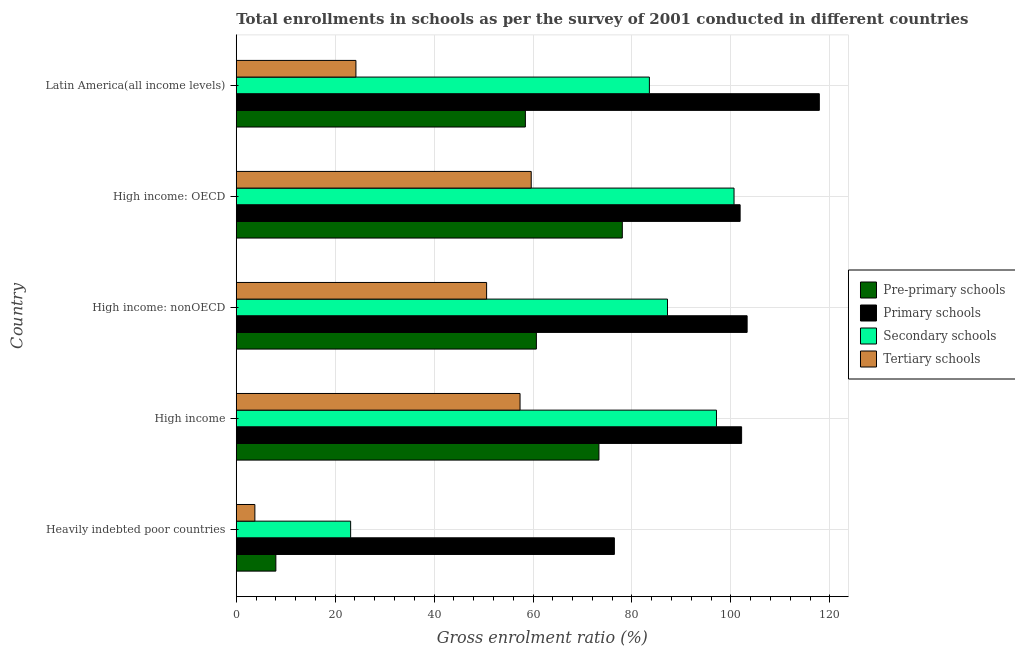Are the number of bars per tick equal to the number of legend labels?
Your answer should be compact. Yes. How many bars are there on the 1st tick from the top?
Offer a terse response. 4. How many bars are there on the 5th tick from the bottom?
Your answer should be very brief. 4. What is the label of the 2nd group of bars from the top?
Your response must be concise. High income: OECD. In how many cases, is the number of bars for a given country not equal to the number of legend labels?
Give a very brief answer. 0. What is the gross enrolment ratio in primary schools in High income: OECD?
Provide a short and direct response. 101.87. Across all countries, what is the maximum gross enrolment ratio in tertiary schools?
Keep it short and to the point. 59.63. Across all countries, what is the minimum gross enrolment ratio in tertiary schools?
Your response must be concise. 3.76. In which country was the gross enrolment ratio in primary schools maximum?
Make the answer very short. Latin America(all income levels). In which country was the gross enrolment ratio in secondary schools minimum?
Your response must be concise. Heavily indebted poor countries. What is the total gross enrolment ratio in pre-primary schools in the graph?
Your answer should be compact. 278.52. What is the difference between the gross enrolment ratio in primary schools in Heavily indebted poor countries and that in High income: OECD?
Make the answer very short. -25.42. What is the difference between the gross enrolment ratio in secondary schools in High income and the gross enrolment ratio in primary schools in High income: OECD?
Your answer should be compact. -4.78. What is the average gross enrolment ratio in pre-primary schools per country?
Your response must be concise. 55.7. What is the difference between the gross enrolment ratio in secondary schools and gross enrolment ratio in pre-primary schools in High income: nonOECD?
Make the answer very short. 26.51. What is the ratio of the gross enrolment ratio in pre-primary schools in High income to that in High income: OECD?
Offer a terse response. 0.94. What is the difference between the highest and the second highest gross enrolment ratio in pre-primary schools?
Ensure brevity in your answer.  4.73. What is the difference between the highest and the lowest gross enrolment ratio in secondary schools?
Provide a succinct answer. 77.51. Is the sum of the gross enrolment ratio in pre-primary schools in High income: OECD and High income: nonOECD greater than the maximum gross enrolment ratio in secondary schools across all countries?
Give a very brief answer. Yes. Is it the case that in every country, the sum of the gross enrolment ratio in tertiary schools and gross enrolment ratio in pre-primary schools is greater than the sum of gross enrolment ratio in primary schools and gross enrolment ratio in secondary schools?
Give a very brief answer. No. What does the 4th bar from the top in High income: OECD represents?
Give a very brief answer. Pre-primary schools. What does the 2nd bar from the bottom in High income represents?
Keep it short and to the point. Primary schools. Is it the case that in every country, the sum of the gross enrolment ratio in pre-primary schools and gross enrolment ratio in primary schools is greater than the gross enrolment ratio in secondary schools?
Your answer should be very brief. Yes. How many bars are there?
Offer a terse response. 20. Are all the bars in the graph horizontal?
Provide a succinct answer. Yes. What is the difference between two consecutive major ticks on the X-axis?
Give a very brief answer. 20. Where does the legend appear in the graph?
Ensure brevity in your answer.  Center right. How many legend labels are there?
Your answer should be very brief. 4. How are the legend labels stacked?
Keep it short and to the point. Vertical. What is the title of the graph?
Make the answer very short. Total enrollments in schools as per the survey of 2001 conducted in different countries. Does "Finland" appear as one of the legend labels in the graph?
Provide a short and direct response. No. What is the label or title of the X-axis?
Make the answer very short. Gross enrolment ratio (%). What is the Gross enrolment ratio (%) in Pre-primary schools in Heavily indebted poor countries?
Your answer should be very brief. 8.01. What is the Gross enrolment ratio (%) in Primary schools in Heavily indebted poor countries?
Your answer should be very brief. 76.45. What is the Gross enrolment ratio (%) in Secondary schools in Heavily indebted poor countries?
Provide a succinct answer. 23.13. What is the Gross enrolment ratio (%) of Tertiary schools in Heavily indebted poor countries?
Ensure brevity in your answer.  3.76. What is the Gross enrolment ratio (%) of Pre-primary schools in High income?
Provide a succinct answer. 73.33. What is the Gross enrolment ratio (%) in Primary schools in High income?
Your answer should be compact. 102.17. What is the Gross enrolment ratio (%) of Secondary schools in High income?
Offer a very short reply. 97.09. What is the Gross enrolment ratio (%) of Tertiary schools in High income?
Offer a terse response. 57.38. What is the Gross enrolment ratio (%) in Pre-primary schools in High income: nonOECD?
Provide a succinct answer. 60.68. What is the Gross enrolment ratio (%) of Primary schools in High income: nonOECD?
Your response must be concise. 103.29. What is the Gross enrolment ratio (%) in Secondary schools in High income: nonOECD?
Make the answer very short. 87.19. What is the Gross enrolment ratio (%) in Tertiary schools in High income: nonOECD?
Keep it short and to the point. 50.62. What is the Gross enrolment ratio (%) of Pre-primary schools in High income: OECD?
Your answer should be compact. 78.05. What is the Gross enrolment ratio (%) of Primary schools in High income: OECD?
Offer a very short reply. 101.87. What is the Gross enrolment ratio (%) in Secondary schools in High income: OECD?
Keep it short and to the point. 100.64. What is the Gross enrolment ratio (%) in Tertiary schools in High income: OECD?
Ensure brevity in your answer.  59.63. What is the Gross enrolment ratio (%) in Pre-primary schools in Latin America(all income levels)?
Your answer should be compact. 58.45. What is the Gross enrolment ratio (%) in Primary schools in Latin America(all income levels)?
Provide a succinct answer. 117.88. What is the Gross enrolment ratio (%) of Secondary schools in Latin America(all income levels)?
Your response must be concise. 83.53. What is the Gross enrolment ratio (%) of Tertiary schools in Latin America(all income levels)?
Offer a very short reply. 24.19. Across all countries, what is the maximum Gross enrolment ratio (%) in Pre-primary schools?
Ensure brevity in your answer.  78.05. Across all countries, what is the maximum Gross enrolment ratio (%) in Primary schools?
Keep it short and to the point. 117.88. Across all countries, what is the maximum Gross enrolment ratio (%) of Secondary schools?
Give a very brief answer. 100.64. Across all countries, what is the maximum Gross enrolment ratio (%) of Tertiary schools?
Your response must be concise. 59.63. Across all countries, what is the minimum Gross enrolment ratio (%) in Pre-primary schools?
Offer a terse response. 8.01. Across all countries, what is the minimum Gross enrolment ratio (%) in Primary schools?
Ensure brevity in your answer.  76.45. Across all countries, what is the minimum Gross enrolment ratio (%) of Secondary schools?
Offer a terse response. 23.13. Across all countries, what is the minimum Gross enrolment ratio (%) of Tertiary schools?
Offer a very short reply. 3.76. What is the total Gross enrolment ratio (%) in Pre-primary schools in the graph?
Make the answer very short. 278.52. What is the total Gross enrolment ratio (%) in Primary schools in the graph?
Offer a very short reply. 501.66. What is the total Gross enrolment ratio (%) of Secondary schools in the graph?
Keep it short and to the point. 391.57. What is the total Gross enrolment ratio (%) in Tertiary schools in the graph?
Keep it short and to the point. 195.58. What is the difference between the Gross enrolment ratio (%) of Pre-primary schools in Heavily indebted poor countries and that in High income?
Give a very brief answer. -65.32. What is the difference between the Gross enrolment ratio (%) in Primary schools in Heavily indebted poor countries and that in High income?
Provide a succinct answer. -25.72. What is the difference between the Gross enrolment ratio (%) of Secondary schools in Heavily indebted poor countries and that in High income?
Provide a short and direct response. -73.96. What is the difference between the Gross enrolment ratio (%) of Tertiary schools in Heavily indebted poor countries and that in High income?
Keep it short and to the point. -53.61. What is the difference between the Gross enrolment ratio (%) in Pre-primary schools in Heavily indebted poor countries and that in High income: nonOECD?
Provide a succinct answer. -52.67. What is the difference between the Gross enrolment ratio (%) of Primary schools in Heavily indebted poor countries and that in High income: nonOECD?
Provide a short and direct response. -26.84. What is the difference between the Gross enrolment ratio (%) in Secondary schools in Heavily indebted poor countries and that in High income: nonOECD?
Offer a terse response. -64.06. What is the difference between the Gross enrolment ratio (%) in Tertiary schools in Heavily indebted poor countries and that in High income: nonOECD?
Offer a very short reply. -46.85. What is the difference between the Gross enrolment ratio (%) of Pre-primary schools in Heavily indebted poor countries and that in High income: OECD?
Offer a terse response. -70.05. What is the difference between the Gross enrolment ratio (%) in Primary schools in Heavily indebted poor countries and that in High income: OECD?
Your answer should be compact. -25.42. What is the difference between the Gross enrolment ratio (%) in Secondary schools in Heavily indebted poor countries and that in High income: OECD?
Your answer should be compact. -77.51. What is the difference between the Gross enrolment ratio (%) of Tertiary schools in Heavily indebted poor countries and that in High income: OECD?
Your answer should be very brief. -55.87. What is the difference between the Gross enrolment ratio (%) in Pre-primary schools in Heavily indebted poor countries and that in Latin America(all income levels)?
Keep it short and to the point. -50.45. What is the difference between the Gross enrolment ratio (%) of Primary schools in Heavily indebted poor countries and that in Latin America(all income levels)?
Give a very brief answer. -41.44. What is the difference between the Gross enrolment ratio (%) in Secondary schools in Heavily indebted poor countries and that in Latin America(all income levels)?
Offer a very short reply. -60.4. What is the difference between the Gross enrolment ratio (%) of Tertiary schools in Heavily indebted poor countries and that in Latin America(all income levels)?
Your answer should be compact. -20.43. What is the difference between the Gross enrolment ratio (%) in Pre-primary schools in High income and that in High income: nonOECD?
Keep it short and to the point. 12.65. What is the difference between the Gross enrolment ratio (%) of Primary schools in High income and that in High income: nonOECD?
Your response must be concise. -1.11. What is the difference between the Gross enrolment ratio (%) of Secondary schools in High income and that in High income: nonOECD?
Your answer should be very brief. 9.9. What is the difference between the Gross enrolment ratio (%) in Tertiary schools in High income and that in High income: nonOECD?
Keep it short and to the point. 6.76. What is the difference between the Gross enrolment ratio (%) in Pre-primary schools in High income and that in High income: OECD?
Your answer should be compact. -4.73. What is the difference between the Gross enrolment ratio (%) in Primary schools in High income and that in High income: OECD?
Keep it short and to the point. 0.3. What is the difference between the Gross enrolment ratio (%) in Secondary schools in High income and that in High income: OECD?
Provide a succinct answer. -3.55. What is the difference between the Gross enrolment ratio (%) in Tertiary schools in High income and that in High income: OECD?
Offer a very short reply. -2.26. What is the difference between the Gross enrolment ratio (%) of Pre-primary schools in High income and that in Latin America(all income levels)?
Ensure brevity in your answer.  14.87. What is the difference between the Gross enrolment ratio (%) of Primary schools in High income and that in Latin America(all income levels)?
Give a very brief answer. -15.71. What is the difference between the Gross enrolment ratio (%) in Secondary schools in High income and that in Latin America(all income levels)?
Make the answer very short. 13.56. What is the difference between the Gross enrolment ratio (%) of Tertiary schools in High income and that in Latin America(all income levels)?
Offer a terse response. 33.18. What is the difference between the Gross enrolment ratio (%) in Pre-primary schools in High income: nonOECD and that in High income: OECD?
Offer a terse response. -17.37. What is the difference between the Gross enrolment ratio (%) of Primary schools in High income: nonOECD and that in High income: OECD?
Your answer should be compact. 1.41. What is the difference between the Gross enrolment ratio (%) of Secondary schools in High income: nonOECD and that in High income: OECD?
Give a very brief answer. -13.45. What is the difference between the Gross enrolment ratio (%) of Tertiary schools in High income: nonOECD and that in High income: OECD?
Your answer should be compact. -9.02. What is the difference between the Gross enrolment ratio (%) of Pre-primary schools in High income: nonOECD and that in Latin America(all income levels)?
Your answer should be compact. 2.23. What is the difference between the Gross enrolment ratio (%) of Primary schools in High income: nonOECD and that in Latin America(all income levels)?
Your answer should be compact. -14.6. What is the difference between the Gross enrolment ratio (%) in Secondary schools in High income: nonOECD and that in Latin America(all income levels)?
Make the answer very short. 3.66. What is the difference between the Gross enrolment ratio (%) of Tertiary schools in High income: nonOECD and that in Latin America(all income levels)?
Your answer should be compact. 26.42. What is the difference between the Gross enrolment ratio (%) in Pre-primary schools in High income: OECD and that in Latin America(all income levels)?
Offer a terse response. 19.6. What is the difference between the Gross enrolment ratio (%) of Primary schools in High income: OECD and that in Latin America(all income levels)?
Keep it short and to the point. -16.01. What is the difference between the Gross enrolment ratio (%) in Secondary schools in High income: OECD and that in Latin America(all income levels)?
Make the answer very short. 17.11. What is the difference between the Gross enrolment ratio (%) of Tertiary schools in High income: OECD and that in Latin America(all income levels)?
Ensure brevity in your answer.  35.44. What is the difference between the Gross enrolment ratio (%) in Pre-primary schools in Heavily indebted poor countries and the Gross enrolment ratio (%) in Primary schools in High income?
Your answer should be very brief. -94.16. What is the difference between the Gross enrolment ratio (%) in Pre-primary schools in Heavily indebted poor countries and the Gross enrolment ratio (%) in Secondary schools in High income?
Offer a terse response. -89.08. What is the difference between the Gross enrolment ratio (%) of Pre-primary schools in Heavily indebted poor countries and the Gross enrolment ratio (%) of Tertiary schools in High income?
Give a very brief answer. -49.37. What is the difference between the Gross enrolment ratio (%) of Primary schools in Heavily indebted poor countries and the Gross enrolment ratio (%) of Secondary schools in High income?
Offer a very short reply. -20.64. What is the difference between the Gross enrolment ratio (%) of Primary schools in Heavily indebted poor countries and the Gross enrolment ratio (%) of Tertiary schools in High income?
Offer a terse response. 19.07. What is the difference between the Gross enrolment ratio (%) of Secondary schools in Heavily indebted poor countries and the Gross enrolment ratio (%) of Tertiary schools in High income?
Your answer should be very brief. -34.25. What is the difference between the Gross enrolment ratio (%) in Pre-primary schools in Heavily indebted poor countries and the Gross enrolment ratio (%) in Primary schools in High income: nonOECD?
Give a very brief answer. -95.28. What is the difference between the Gross enrolment ratio (%) in Pre-primary schools in Heavily indebted poor countries and the Gross enrolment ratio (%) in Secondary schools in High income: nonOECD?
Your answer should be compact. -79.18. What is the difference between the Gross enrolment ratio (%) in Pre-primary schools in Heavily indebted poor countries and the Gross enrolment ratio (%) in Tertiary schools in High income: nonOECD?
Offer a terse response. -42.61. What is the difference between the Gross enrolment ratio (%) of Primary schools in Heavily indebted poor countries and the Gross enrolment ratio (%) of Secondary schools in High income: nonOECD?
Offer a terse response. -10.74. What is the difference between the Gross enrolment ratio (%) of Primary schools in Heavily indebted poor countries and the Gross enrolment ratio (%) of Tertiary schools in High income: nonOECD?
Your response must be concise. 25.83. What is the difference between the Gross enrolment ratio (%) in Secondary schools in Heavily indebted poor countries and the Gross enrolment ratio (%) in Tertiary schools in High income: nonOECD?
Provide a short and direct response. -27.49. What is the difference between the Gross enrolment ratio (%) in Pre-primary schools in Heavily indebted poor countries and the Gross enrolment ratio (%) in Primary schools in High income: OECD?
Provide a succinct answer. -93.86. What is the difference between the Gross enrolment ratio (%) in Pre-primary schools in Heavily indebted poor countries and the Gross enrolment ratio (%) in Secondary schools in High income: OECD?
Give a very brief answer. -92.63. What is the difference between the Gross enrolment ratio (%) of Pre-primary schools in Heavily indebted poor countries and the Gross enrolment ratio (%) of Tertiary schools in High income: OECD?
Give a very brief answer. -51.63. What is the difference between the Gross enrolment ratio (%) in Primary schools in Heavily indebted poor countries and the Gross enrolment ratio (%) in Secondary schools in High income: OECD?
Offer a terse response. -24.19. What is the difference between the Gross enrolment ratio (%) of Primary schools in Heavily indebted poor countries and the Gross enrolment ratio (%) of Tertiary schools in High income: OECD?
Give a very brief answer. 16.81. What is the difference between the Gross enrolment ratio (%) of Secondary schools in Heavily indebted poor countries and the Gross enrolment ratio (%) of Tertiary schools in High income: OECD?
Your response must be concise. -36.51. What is the difference between the Gross enrolment ratio (%) in Pre-primary schools in Heavily indebted poor countries and the Gross enrolment ratio (%) in Primary schools in Latin America(all income levels)?
Keep it short and to the point. -109.88. What is the difference between the Gross enrolment ratio (%) in Pre-primary schools in Heavily indebted poor countries and the Gross enrolment ratio (%) in Secondary schools in Latin America(all income levels)?
Your answer should be very brief. -75.52. What is the difference between the Gross enrolment ratio (%) of Pre-primary schools in Heavily indebted poor countries and the Gross enrolment ratio (%) of Tertiary schools in Latin America(all income levels)?
Offer a terse response. -16.19. What is the difference between the Gross enrolment ratio (%) in Primary schools in Heavily indebted poor countries and the Gross enrolment ratio (%) in Secondary schools in Latin America(all income levels)?
Your response must be concise. -7.08. What is the difference between the Gross enrolment ratio (%) in Primary schools in Heavily indebted poor countries and the Gross enrolment ratio (%) in Tertiary schools in Latin America(all income levels)?
Your response must be concise. 52.25. What is the difference between the Gross enrolment ratio (%) of Secondary schools in Heavily indebted poor countries and the Gross enrolment ratio (%) of Tertiary schools in Latin America(all income levels)?
Provide a succinct answer. -1.07. What is the difference between the Gross enrolment ratio (%) of Pre-primary schools in High income and the Gross enrolment ratio (%) of Primary schools in High income: nonOECD?
Offer a very short reply. -29.96. What is the difference between the Gross enrolment ratio (%) in Pre-primary schools in High income and the Gross enrolment ratio (%) in Secondary schools in High income: nonOECD?
Provide a succinct answer. -13.86. What is the difference between the Gross enrolment ratio (%) in Pre-primary schools in High income and the Gross enrolment ratio (%) in Tertiary schools in High income: nonOECD?
Keep it short and to the point. 22.71. What is the difference between the Gross enrolment ratio (%) of Primary schools in High income and the Gross enrolment ratio (%) of Secondary schools in High income: nonOECD?
Your answer should be compact. 14.98. What is the difference between the Gross enrolment ratio (%) in Primary schools in High income and the Gross enrolment ratio (%) in Tertiary schools in High income: nonOECD?
Offer a very short reply. 51.56. What is the difference between the Gross enrolment ratio (%) of Secondary schools in High income and the Gross enrolment ratio (%) of Tertiary schools in High income: nonOECD?
Make the answer very short. 46.47. What is the difference between the Gross enrolment ratio (%) in Pre-primary schools in High income and the Gross enrolment ratio (%) in Primary schools in High income: OECD?
Provide a short and direct response. -28.54. What is the difference between the Gross enrolment ratio (%) of Pre-primary schools in High income and the Gross enrolment ratio (%) of Secondary schools in High income: OECD?
Ensure brevity in your answer.  -27.31. What is the difference between the Gross enrolment ratio (%) of Pre-primary schools in High income and the Gross enrolment ratio (%) of Tertiary schools in High income: OECD?
Make the answer very short. 13.69. What is the difference between the Gross enrolment ratio (%) in Primary schools in High income and the Gross enrolment ratio (%) in Secondary schools in High income: OECD?
Your answer should be compact. 1.53. What is the difference between the Gross enrolment ratio (%) of Primary schools in High income and the Gross enrolment ratio (%) of Tertiary schools in High income: OECD?
Give a very brief answer. 42.54. What is the difference between the Gross enrolment ratio (%) in Secondary schools in High income and the Gross enrolment ratio (%) in Tertiary schools in High income: OECD?
Provide a short and direct response. 37.45. What is the difference between the Gross enrolment ratio (%) in Pre-primary schools in High income and the Gross enrolment ratio (%) in Primary schools in Latin America(all income levels)?
Offer a terse response. -44.56. What is the difference between the Gross enrolment ratio (%) in Pre-primary schools in High income and the Gross enrolment ratio (%) in Secondary schools in Latin America(all income levels)?
Offer a very short reply. -10.2. What is the difference between the Gross enrolment ratio (%) in Pre-primary schools in High income and the Gross enrolment ratio (%) in Tertiary schools in Latin America(all income levels)?
Ensure brevity in your answer.  49.13. What is the difference between the Gross enrolment ratio (%) in Primary schools in High income and the Gross enrolment ratio (%) in Secondary schools in Latin America(all income levels)?
Make the answer very short. 18.64. What is the difference between the Gross enrolment ratio (%) in Primary schools in High income and the Gross enrolment ratio (%) in Tertiary schools in Latin America(all income levels)?
Your answer should be compact. 77.98. What is the difference between the Gross enrolment ratio (%) of Secondary schools in High income and the Gross enrolment ratio (%) of Tertiary schools in Latin America(all income levels)?
Ensure brevity in your answer.  72.9. What is the difference between the Gross enrolment ratio (%) of Pre-primary schools in High income: nonOECD and the Gross enrolment ratio (%) of Primary schools in High income: OECD?
Provide a short and direct response. -41.19. What is the difference between the Gross enrolment ratio (%) in Pre-primary schools in High income: nonOECD and the Gross enrolment ratio (%) in Secondary schools in High income: OECD?
Make the answer very short. -39.96. What is the difference between the Gross enrolment ratio (%) in Pre-primary schools in High income: nonOECD and the Gross enrolment ratio (%) in Tertiary schools in High income: OECD?
Offer a very short reply. 1.04. What is the difference between the Gross enrolment ratio (%) in Primary schools in High income: nonOECD and the Gross enrolment ratio (%) in Secondary schools in High income: OECD?
Provide a succinct answer. 2.65. What is the difference between the Gross enrolment ratio (%) in Primary schools in High income: nonOECD and the Gross enrolment ratio (%) in Tertiary schools in High income: OECD?
Your response must be concise. 43.65. What is the difference between the Gross enrolment ratio (%) of Secondary schools in High income: nonOECD and the Gross enrolment ratio (%) of Tertiary schools in High income: OECD?
Ensure brevity in your answer.  27.55. What is the difference between the Gross enrolment ratio (%) in Pre-primary schools in High income: nonOECD and the Gross enrolment ratio (%) in Primary schools in Latin America(all income levels)?
Your answer should be compact. -57.2. What is the difference between the Gross enrolment ratio (%) of Pre-primary schools in High income: nonOECD and the Gross enrolment ratio (%) of Secondary schools in Latin America(all income levels)?
Keep it short and to the point. -22.85. What is the difference between the Gross enrolment ratio (%) in Pre-primary schools in High income: nonOECD and the Gross enrolment ratio (%) in Tertiary schools in Latin America(all income levels)?
Your response must be concise. 36.49. What is the difference between the Gross enrolment ratio (%) of Primary schools in High income: nonOECD and the Gross enrolment ratio (%) of Secondary schools in Latin America(all income levels)?
Offer a very short reply. 19.76. What is the difference between the Gross enrolment ratio (%) of Primary schools in High income: nonOECD and the Gross enrolment ratio (%) of Tertiary schools in Latin America(all income levels)?
Provide a short and direct response. 79.09. What is the difference between the Gross enrolment ratio (%) of Secondary schools in High income: nonOECD and the Gross enrolment ratio (%) of Tertiary schools in Latin America(all income levels)?
Ensure brevity in your answer.  62.99. What is the difference between the Gross enrolment ratio (%) in Pre-primary schools in High income: OECD and the Gross enrolment ratio (%) in Primary schools in Latin America(all income levels)?
Give a very brief answer. -39.83. What is the difference between the Gross enrolment ratio (%) in Pre-primary schools in High income: OECD and the Gross enrolment ratio (%) in Secondary schools in Latin America(all income levels)?
Your response must be concise. -5.47. What is the difference between the Gross enrolment ratio (%) in Pre-primary schools in High income: OECD and the Gross enrolment ratio (%) in Tertiary schools in Latin America(all income levels)?
Your answer should be very brief. 53.86. What is the difference between the Gross enrolment ratio (%) in Primary schools in High income: OECD and the Gross enrolment ratio (%) in Secondary schools in Latin America(all income levels)?
Your answer should be compact. 18.34. What is the difference between the Gross enrolment ratio (%) in Primary schools in High income: OECD and the Gross enrolment ratio (%) in Tertiary schools in Latin America(all income levels)?
Your answer should be very brief. 77.68. What is the difference between the Gross enrolment ratio (%) in Secondary schools in High income: OECD and the Gross enrolment ratio (%) in Tertiary schools in Latin America(all income levels)?
Your answer should be compact. 76.45. What is the average Gross enrolment ratio (%) of Pre-primary schools per country?
Provide a short and direct response. 55.7. What is the average Gross enrolment ratio (%) of Primary schools per country?
Offer a very short reply. 100.33. What is the average Gross enrolment ratio (%) in Secondary schools per country?
Provide a succinct answer. 78.31. What is the average Gross enrolment ratio (%) of Tertiary schools per country?
Provide a short and direct response. 39.12. What is the difference between the Gross enrolment ratio (%) in Pre-primary schools and Gross enrolment ratio (%) in Primary schools in Heavily indebted poor countries?
Give a very brief answer. -68.44. What is the difference between the Gross enrolment ratio (%) in Pre-primary schools and Gross enrolment ratio (%) in Secondary schools in Heavily indebted poor countries?
Keep it short and to the point. -15.12. What is the difference between the Gross enrolment ratio (%) of Pre-primary schools and Gross enrolment ratio (%) of Tertiary schools in Heavily indebted poor countries?
Your answer should be compact. 4.24. What is the difference between the Gross enrolment ratio (%) of Primary schools and Gross enrolment ratio (%) of Secondary schools in Heavily indebted poor countries?
Your answer should be compact. 53.32. What is the difference between the Gross enrolment ratio (%) in Primary schools and Gross enrolment ratio (%) in Tertiary schools in Heavily indebted poor countries?
Your response must be concise. 72.68. What is the difference between the Gross enrolment ratio (%) of Secondary schools and Gross enrolment ratio (%) of Tertiary schools in Heavily indebted poor countries?
Your answer should be compact. 19.36. What is the difference between the Gross enrolment ratio (%) in Pre-primary schools and Gross enrolment ratio (%) in Primary schools in High income?
Provide a short and direct response. -28.85. What is the difference between the Gross enrolment ratio (%) in Pre-primary schools and Gross enrolment ratio (%) in Secondary schools in High income?
Provide a succinct answer. -23.76. What is the difference between the Gross enrolment ratio (%) in Pre-primary schools and Gross enrolment ratio (%) in Tertiary schools in High income?
Your answer should be very brief. 15.95. What is the difference between the Gross enrolment ratio (%) of Primary schools and Gross enrolment ratio (%) of Secondary schools in High income?
Provide a short and direct response. 5.08. What is the difference between the Gross enrolment ratio (%) in Primary schools and Gross enrolment ratio (%) in Tertiary schools in High income?
Ensure brevity in your answer.  44.8. What is the difference between the Gross enrolment ratio (%) in Secondary schools and Gross enrolment ratio (%) in Tertiary schools in High income?
Your answer should be very brief. 39.71. What is the difference between the Gross enrolment ratio (%) of Pre-primary schools and Gross enrolment ratio (%) of Primary schools in High income: nonOECD?
Offer a terse response. -42.61. What is the difference between the Gross enrolment ratio (%) in Pre-primary schools and Gross enrolment ratio (%) in Secondary schools in High income: nonOECD?
Your answer should be very brief. -26.51. What is the difference between the Gross enrolment ratio (%) of Pre-primary schools and Gross enrolment ratio (%) of Tertiary schools in High income: nonOECD?
Keep it short and to the point. 10.06. What is the difference between the Gross enrolment ratio (%) in Primary schools and Gross enrolment ratio (%) in Secondary schools in High income: nonOECD?
Your answer should be compact. 16.1. What is the difference between the Gross enrolment ratio (%) in Primary schools and Gross enrolment ratio (%) in Tertiary schools in High income: nonOECD?
Your answer should be very brief. 52.67. What is the difference between the Gross enrolment ratio (%) in Secondary schools and Gross enrolment ratio (%) in Tertiary schools in High income: nonOECD?
Your answer should be very brief. 36.57. What is the difference between the Gross enrolment ratio (%) in Pre-primary schools and Gross enrolment ratio (%) in Primary schools in High income: OECD?
Your response must be concise. -23.82. What is the difference between the Gross enrolment ratio (%) in Pre-primary schools and Gross enrolment ratio (%) in Secondary schools in High income: OECD?
Ensure brevity in your answer.  -22.59. What is the difference between the Gross enrolment ratio (%) of Pre-primary schools and Gross enrolment ratio (%) of Tertiary schools in High income: OECD?
Your answer should be very brief. 18.42. What is the difference between the Gross enrolment ratio (%) of Primary schools and Gross enrolment ratio (%) of Secondary schools in High income: OECD?
Your answer should be very brief. 1.23. What is the difference between the Gross enrolment ratio (%) in Primary schools and Gross enrolment ratio (%) in Tertiary schools in High income: OECD?
Your response must be concise. 42.24. What is the difference between the Gross enrolment ratio (%) of Secondary schools and Gross enrolment ratio (%) of Tertiary schools in High income: OECD?
Offer a terse response. 41.01. What is the difference between the Gross enrolment ratio (%) of Pre-primary schools and Gross enrolment ratio (%) of Primary schools in Latin America(all income levels)?
Your answer should be compact. -59.43. What is the difference between the Gross enrolment ratio (%) in Pre-primary schools and Gross enrolment ratio (%) in Secondary schools in Latin America(all income levels)?
Ensure brevity in your answer.  -25.07. What is the difference between the Gross enrolment ratio (%) in Pre-primary schools and Gross enrolment ratio (%) in Tertiary schools in Latin America(all income levels)?
Ensure brevity in your answer.  34.26. What is the difference between the Gross enrolment ratio (%) in Primary schools and Gross enrolment ratio (%) in Secondary schools in Latin America(all income levels)?
Your answer should be compact. 34.36. What is the difference between the Gross enrolment ratio (%) in Primary schools and Gross enrolment ratio (%) in Tertiary schools in Latin America(all income levels)?
Offer a terse response. 93.69. What is the difference between the Gross enrolment ratio (%) of Secondary schools and Gross enrolment ratio (%) of Tertiary schools in Latin America(all income levels)?
Offer a terse response. 59.33. What is the ratio of the Gross enrolment ratio (%) of Pre-primary schools in Heavily indebted poor countries to that in High income?
Your response must be concise. 0.11. What is the ratio of the Gross enrolment ratio (%) of Primary schools in Heavily indebted poor countries to that in High income?
Offer a terse response. 0.75. What is the ratio of the Gross enrolment ratio (%) of Secondary schools in Heavily indebted poor countries to that in High income?
Make the answer very short. 0.24. What is the ratio of the Gross enrolment ratio (%) of Tertiary schools in Heavily indebted poor countries to that in High income?
Your answer should be very brief. 0.07. What is the ratio of the Gross enrolment ratio (%) in Pre-primary schools in Heavily indebted poor countries to that in High income: nonOECD?
Offer a very short reply. 0.13. What is the ratio of the Gross enrolment ratio (%) in Primary schools in Heavily indebted poor countries to that in High income: nonOECD?
Provide a short and direct response. 0.74. What is the ratio of the Gross enrolment ratio (%) in Secondary schools in Heavily indebted poor countries to that in High income: nonOECD?
Your answer should be very brief. 0.27. What is the ratio of the Gross enrolment ratio (%) of Tertiary schools in Heavily indebted poor countries to that in High income: nonOECD?
Keep it short and to the point. 0.07. What is the ratio of the Gross enrolment ratio (%) of Pre-primary schools in Heavily indebted poor countries to that in High income: OECD?
Offer a very short reply. 0.1. What is the ratio of the Gross enrolment ratio (%) of Primary schools in Heavily indebted poor countries to that in High income: OECD?
Offer a very short reply. 0.75. What is the ratio of the Gross enrolment ratio (%) of Secondary schools in Heavily indebted poor countries to that in High income: OECD?
Give a very brief answer. 0.23. What is the ratio of the Gross enrolment ratio (%) of Tertiary schools in Heavily indebted poor countries to that in High income: OECD?
Your response must be concise. 0.06. What is the ratio of the Gross enrolment ratio (%) in Pre-primary schools in Heavily indebted poor countries to that in Latin America(all income levels)?
Offer a terse response. 0.14. What is the ratio of the Gross enrolment ratio (%) of Primary schools in Heavily indebted poor countries to that in Latin America(all income levels)?
Your response must be concise. 0.65. What is the ratio of the Gross enrolment ratio (%) of Secondary schools in Heavily indebted poor countries to that in Latin America(all income levels)?
Ensure brevity in your answer.  0.28. What is the ratio of the Gross enrolment ratio (%) in Tertiary schools in Heavily indebted poor countries to that in Latin America(all income levels)?
Ensure brevity in your answer.  0.16. What is the ratio of the Gross enrolment ratio (%) in Pre-primary schools in High income to that in High income: nonOECD?
Provide a short and direct response. 1.21. What is the ratio of the Gross enrolment ratio (%) in Secondary schools in High income to that in High income: nonOECD?
Give a very brief answer. 1.11. What is the ratio of the Gross enrolment ratio (%) of Tertiary schools in High income to that in High income: nonOECD?
Offer a very short reply. 1.13. What is the ratio of the Gross enrolment ratio (%) in Pre-primary schools in High income to that in High income: OECD?
Your answer should be compact. 0.94. What is the ratio of the Gross enrolment ratio (%) of Secondary schools in High income to that in High income: OECD?
Provide a succinct answer. 0.96. What is the ratio of the Gross enrolment ratio (%) of Tertiary schools in High income to that in High income: OECD?
Give a very brief answer. 0.96. What is the ratio of the Gross enrolment ratio (%) of Pre-primary schools in High income to that in Latin America(all income levels)?
Make the answer very short. 1.25. What is the ratio of the Gross enrolment ratio (%) in Primary schools in High income to that in Latin America(all income levels)?
Offer a very short reply. 0.87. What is the ratio of the Gross enrolment ratio (%) of Secondary schools in High income to that in Latin America(all income levels)?
Make the answer very short. 1.16. What is the ratio of the Gross enrolment ratio (%) of Tertiary schools in High income to that in Latin America(all income levels)?
Give a very brief answer. 2.37. What is the ratio of the Gross enrolment ratio (%) in Pre-primary schools in High income: nonOECD to that in High income: OECD?
Keep it short and to the point. 0.78. What is the ratio of the Gross enrolment ratio (%) of Primary schools in High income: nonOECD to that in High income: OECD?
Your answer should be compact. 1.01. What is the ratio of the Gross enrolment ratio (%) in Secondary schools in High income: nonOECD to that in High income: OECD?
Give a very brief answer. 0.87. What is the ratio of the Gross enrolment ratio (%) in Tertiary schools in High income: nonOECD to that in High income: OECD?
Provide a succinct answer. 0.85. What is the ratio of the Gross enrolment ratio (%) in Pre-primary schools in High income: nonOECD to that in Latin America(all income levels)?
Your answer should be compact. 1.04. What is the ratio of the Gross enrolment ratio (%) in Primary schools in High income: nonOECD to that in Latin America(all income levels)?
Provide a succinct answer. 0.88. What is the ratio of the Gross enrolment ratio (%) in Secondary schools in High income: nonOECD to that in Latin America(all income levels)?
Offer a very short reply. 1.04. What is the ratio of the Gross enrolment ratio (%) in Tertiary schools in High income: nonOECD to that in Latin America(all income levels)?
Your answer should be very brief. 2.09. What is the ratio of the Gross enrolment ratio (%) of Pre-primary schools in High income: OECD to that in Latin America(all income levels)?
Ensure brevity in your answer.  1.34. What is the ratio of the Gross enrolment ratio (%) in Primary schools in High income: OECD to that in Latin America(all income levels)?
Offer a very short reply. 0.86. What is the ratio of the Gross enrolment ratio (%) in Secondary schools in High income: OECD to that in Latin America(all income levels)?
Make the answer very short. 1.2. What is the ratio of the Gross enrolment ratio (%) in Tertiary schools in High income: OECD to that in Latin America(all income levels)?
Offer a terse response. 2.46. What is the difference between the highest and the second highest Gross enrolment ratio (%) of Pre-primary schools?
Your answer should be very brief. 4.73. What is the difference between the highest and the second highest Gross enrolment ratio (%) of Primary schools?
Make the answer very short. 14.6. What is the difference between the highest and the second highest Gross enrolment ratio (%) of Secondary schools?
Your answer should be very brief. 3.55. What is the difference between the highest and the second highest Gross enrolment ratio (%) of Tertiary schools?
Your answer should be very brief. 2.26. What is the difference between the highest and the lowest Gross enrolment ratio (%) of Pre-primary schools?
Offer a very short reply. 70.05. What is the difference between the highest and the lowest Gross enrolment ratio (%) of Primary schools?
Provide a succinct answer. 41.44. What is the difference between the highest and the lowest Gross enrolment ratio (%) in Secondary schools?
Provide a short and direct response. 77.51. What is the difference between the highest and the lowest Gross enrolment ratio (%) of Tertiary schools?
Ensure brevity in your answer.  55.87. 